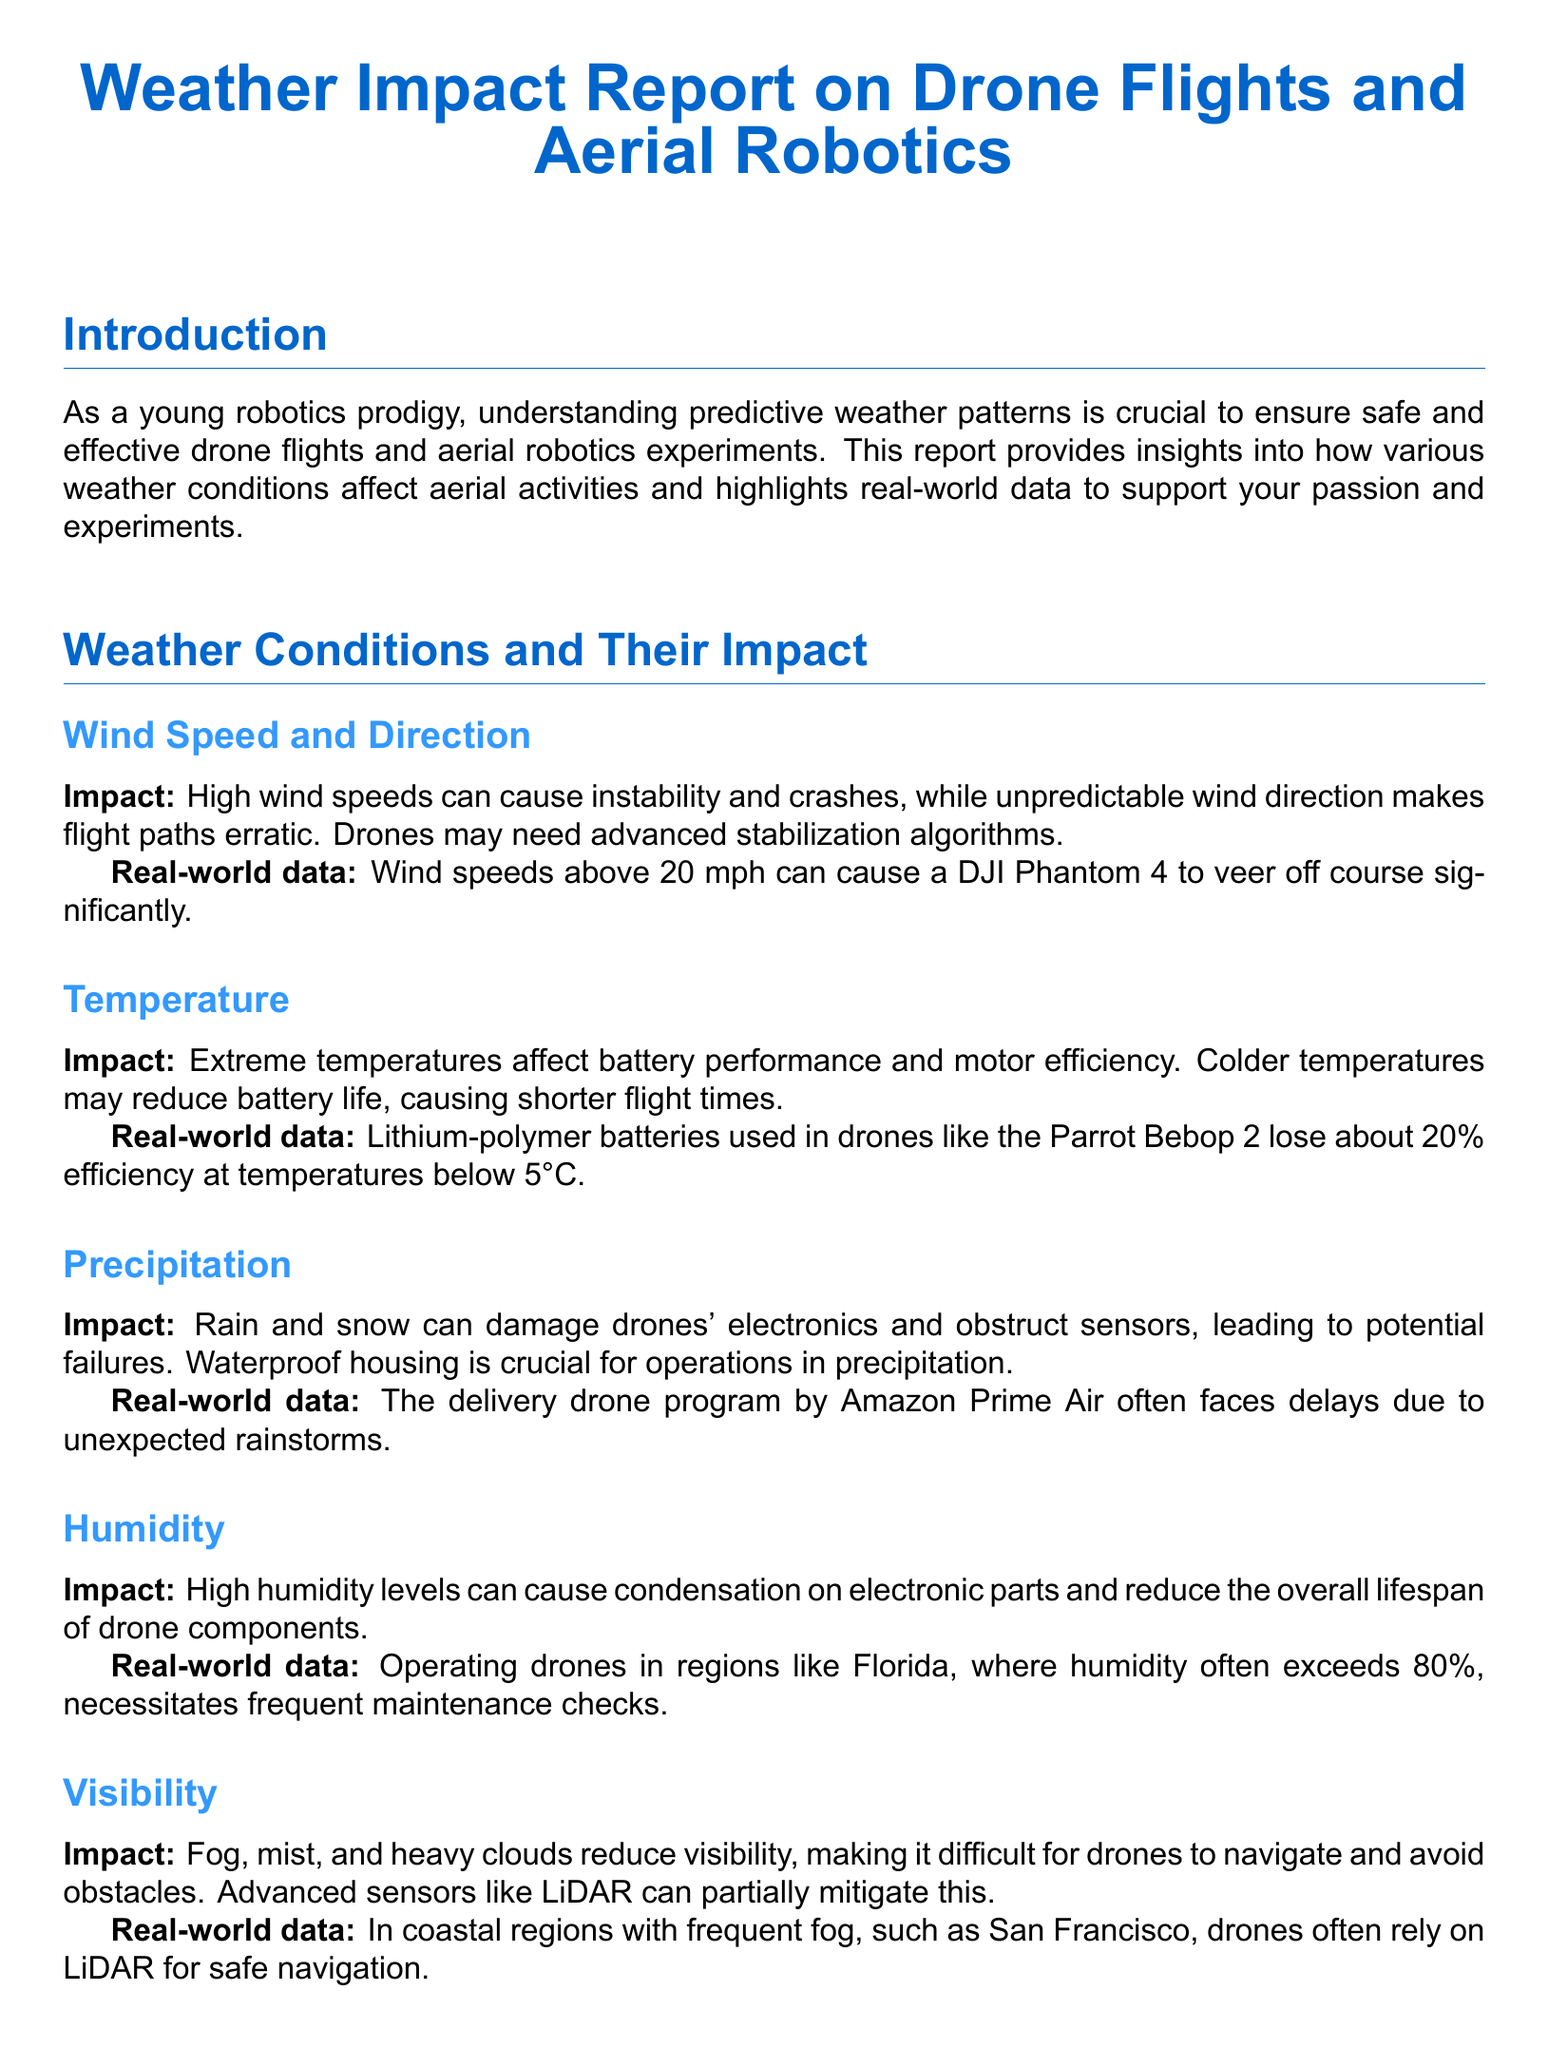what is the focus of this report? The report focuses on how various weather conditions impact drone flights and aerial robotics experiments.
Answer: weather conditions what wind speed is mentioned as having a significant impact? The document states that wind speeds above 20 mph can significantly affect drone navigation.
Answer: 20 mph how much efficiency do lithium-polymer batteries lose below 5°C? The report indicates that these batteries lose about 20% efficiency at lower temperatures.
Answer: 20% what is a crucial feature for drones operating in precipitation? The report emphasizes that waterproof housing is crucial for operations in rain and snow.
Answer: waterproof housing which advanced sensor is suggested for navigation in fog? The report suggests the use of LiDAR to mitigate navigation issues in foggy conditions.
Answer: LiDAR what type of support is called for in the conclusion? The conclusion urges for support from educational institutions, tech companies, and philanthropists.
Answer: support which area's humidity levels necessitate frequent maintenance checks? The document refers to regions like Florida with high humidity levels requiring maintenance.
Answer: Florida what is a suggested future investment to address weather challenges? The report mentions that investment in better materials and sensor technology is essential.
Answer: better materials how do extreme temperatures affect drone operations? Extreme temperatures affect battery performance and motor efficiency, shortening flight times.
Answer: battery performance 